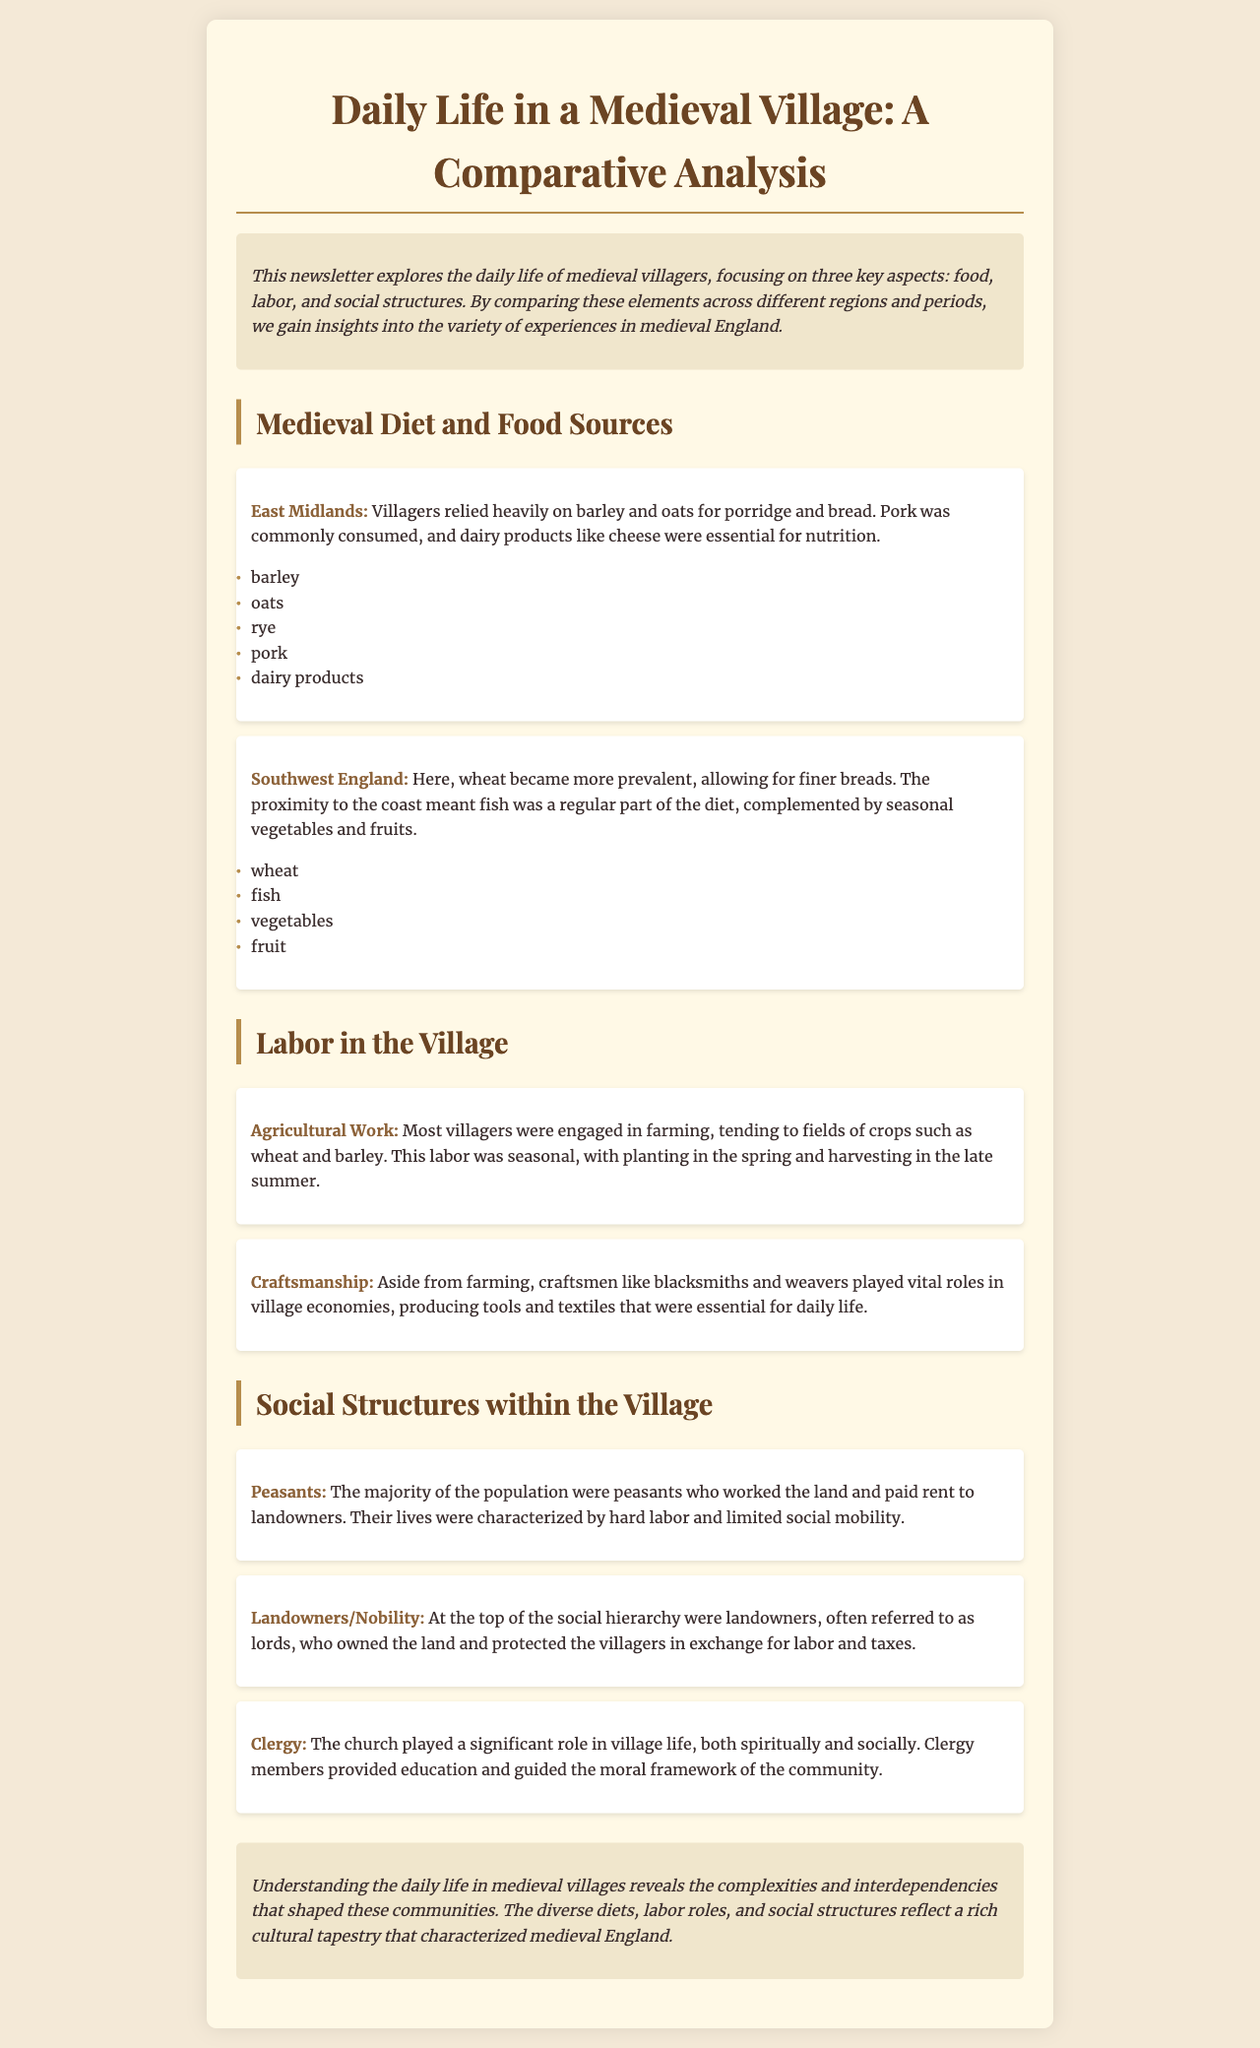What grains were common in the East Midlands diet? The document lists barley and oats as common grains consumed in the East Midlands diet.
Answer: barley and oats Which type of fish was a staple in the Southwest England diet? The Southwest England diet included fish as a regular part, highlighting its significance in local food sources.
Answer: fish What labor engaged most villagers in agriculture? The document states that most villagers were engaged in farming, specifically mentioning the crops they tended to.
Answer: farming Which class made up the majority of the population in medieval villages? The document indicates that the majority of the population consisted of peasants who worked the land.
Answer: Peasants What role did the clergy play in village life? The document mentions that members of the clergy provided education and guided the moral framework of the community.
Answer: education and moral guidance What crop was associated with agricultural work during late summer? The labor of harvesting is associated with a specific time of year mentioned in the document, focusing on the crops produced.
Answer: harvesting What type of craftsmanship was mentioned as vital in village economies? The document highlights craftsmanship as essential, specifically naming a type of craftsman that produced important tools.
Answer: blacksmiths What was the relationship between landowners and villagers? The document explains the dynamic between landowners and villagers, noting the obligations tied to land usage and labor.
Answer: labor and taxes In what geographical area was wheat more prevalent? The document explicitly states that wheat became more prevalent in one specific region of England's medieval diet.
Answer: Southwest England 